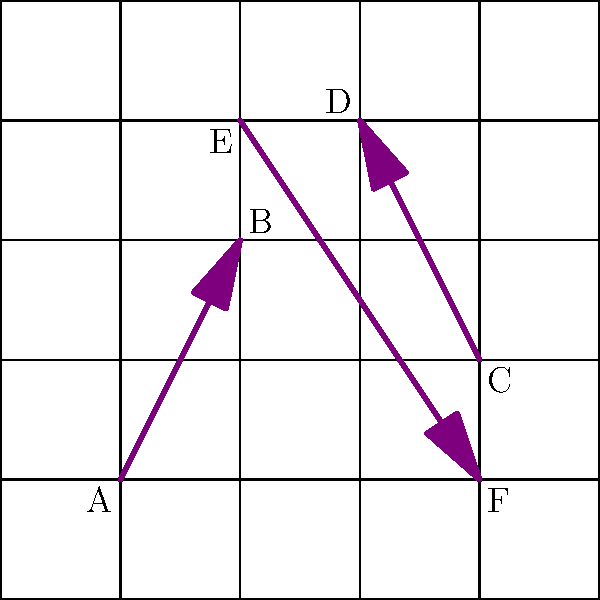In this 2D grid representation of interdimensional portals, each arrow represents a one-way portal from one point to another. If you start at point A and can only travel through portals, how many unique points (including A) can you reach? Let's trace the path step-by-step:

1. We start at point A (1,1).
2. From A, we can only go to B (2,3).
3. From B, there are no outgoing portals.
4. We cannot reach C (4,2) or D (3,4) from A or B.
5. We cannot reach E (2,4) directly, but we need to check if it's reachable from other points we can access.
6. We cannot reach F (4,1) directly, but we need to check if it's reachable from other points we can access.
7. After checking all possibilities, we confirm that no other points are reachable from A or B.

Therefore, starting from A, we can only reach 2 unique points: A itself and B.
Answer: 2 